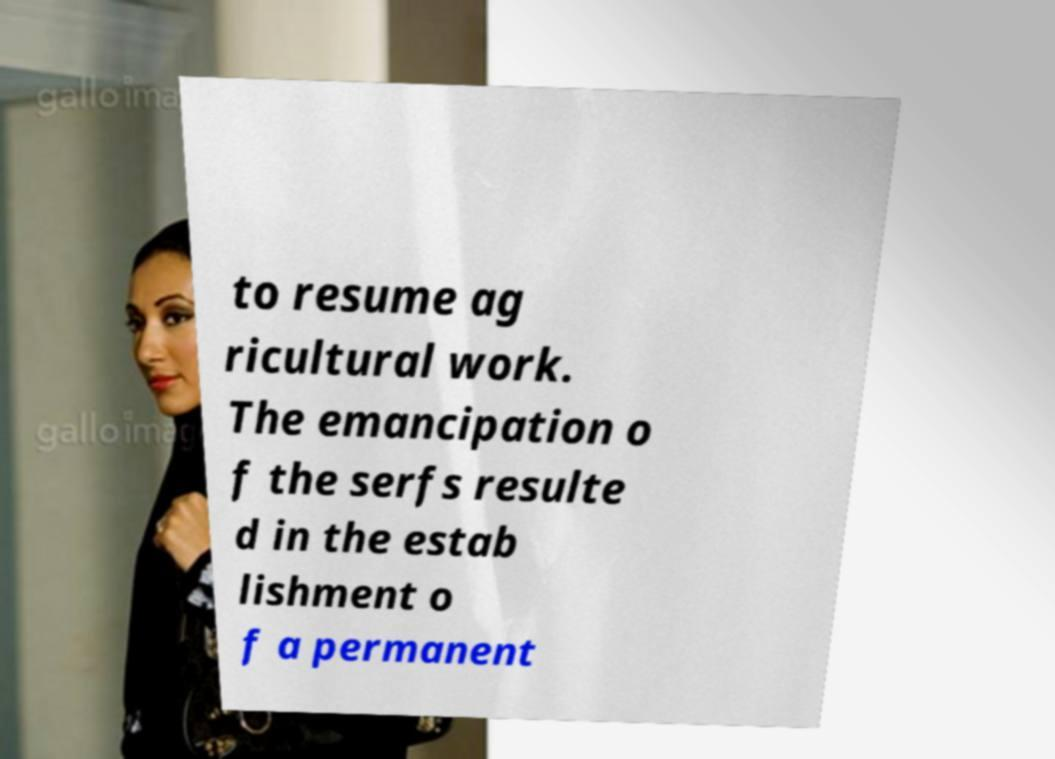Please read and relay the text visible in this image. What does it say? to resume ag ricultural work. The emancipation o f the serfs resulte d in the estab lishment o f a permanent 